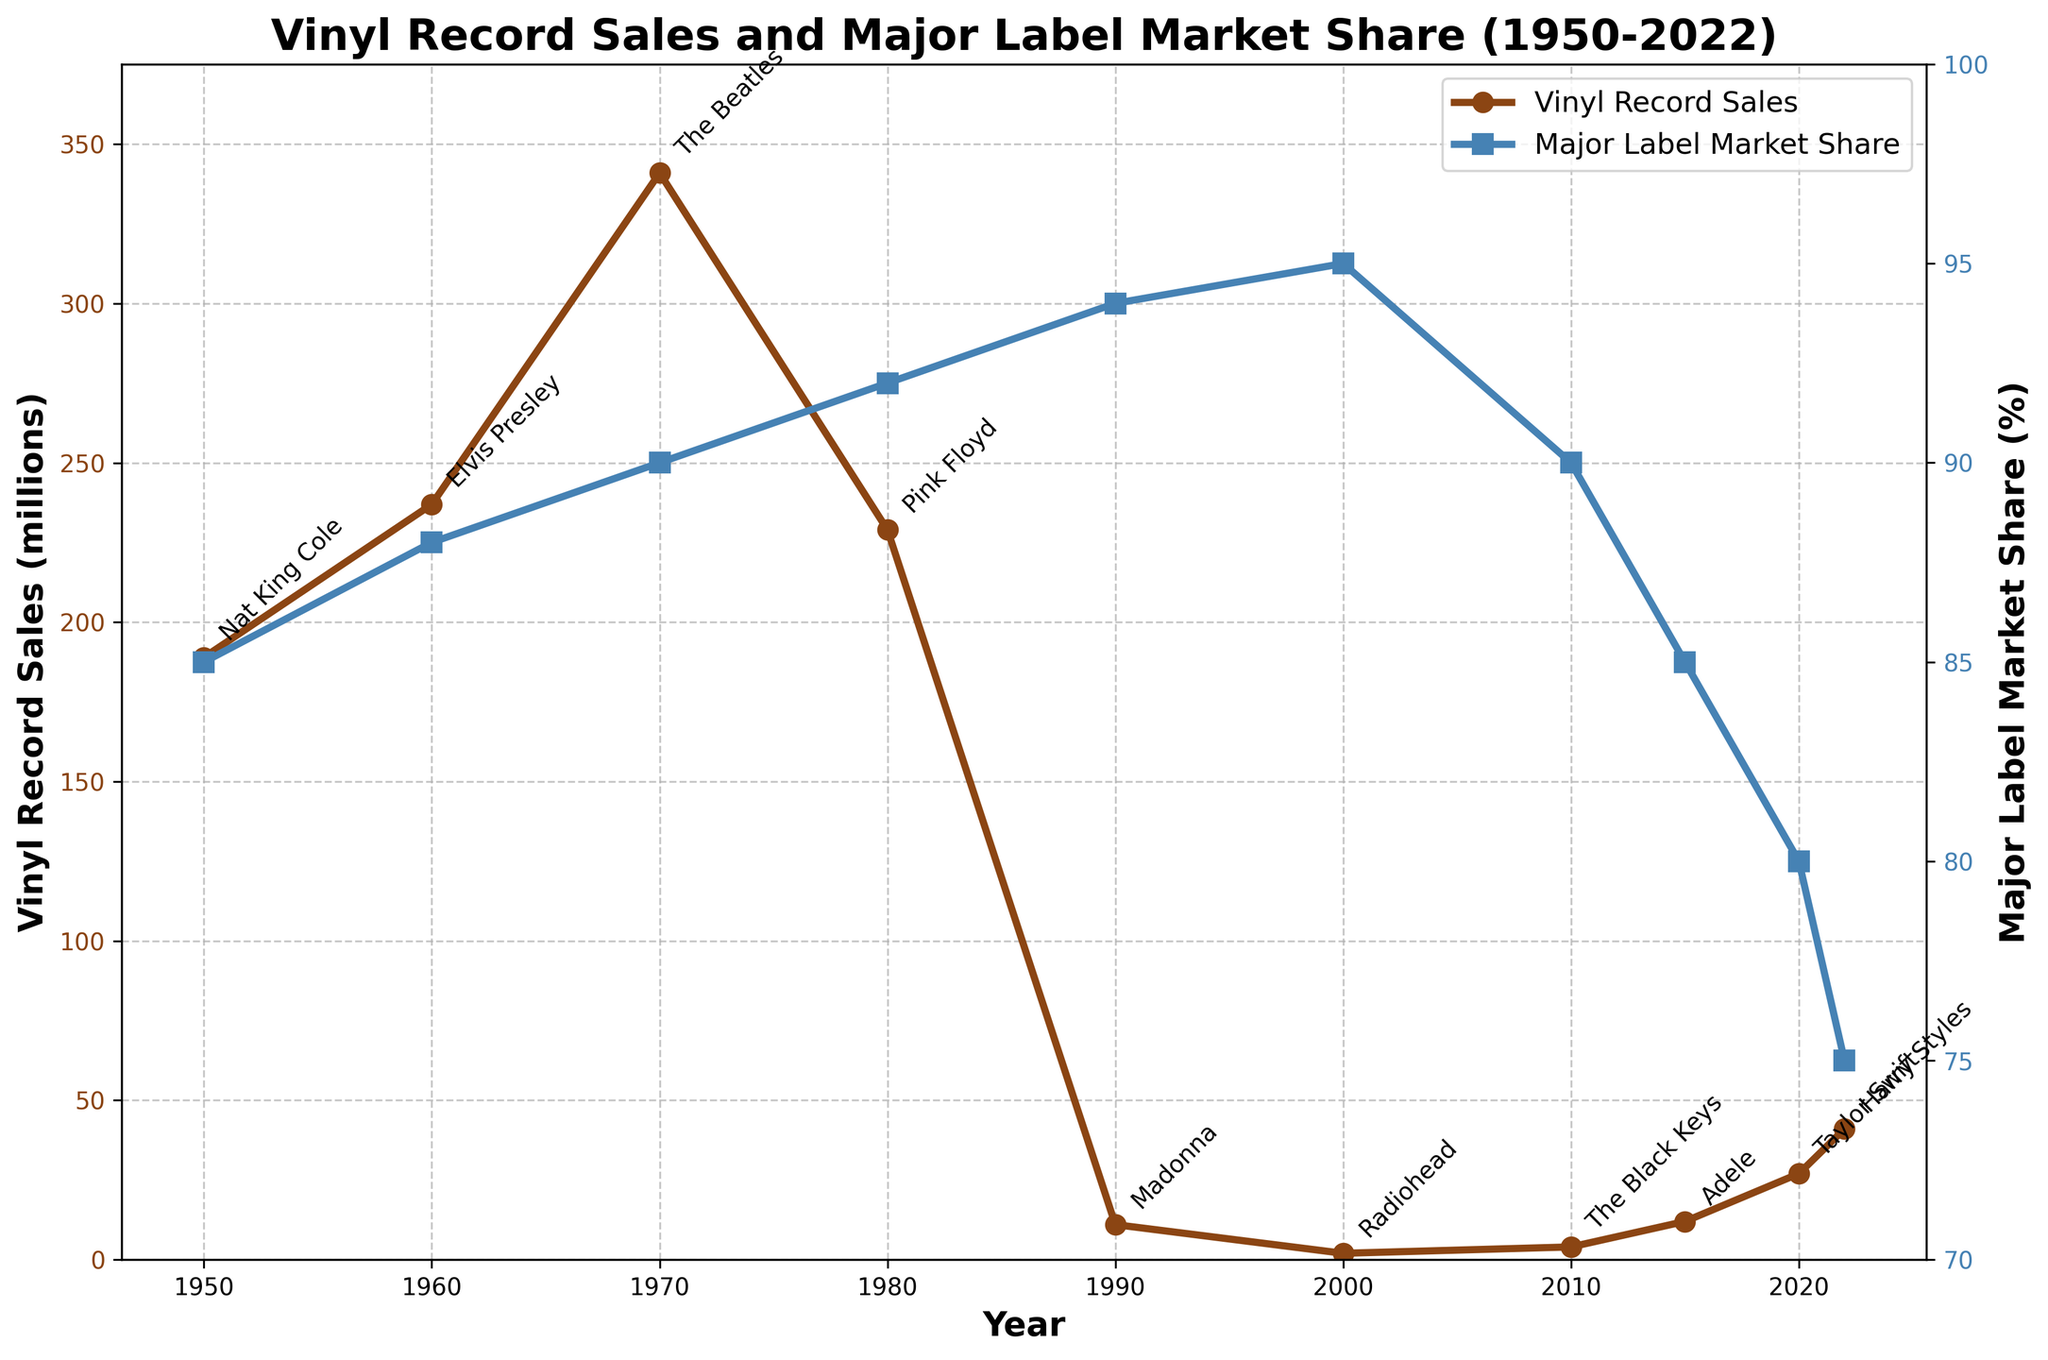What's the lowest point of vinyl record sales in the graph? The lowest point of vinyl record sales is when the data marker is closest to the bottom of the y-axis representing sales. This occurs in the year 2000.
Answer: 2000 What's the increase in vinyl record sales from 2010 to 2020? To find the increase, subtract the sales in 2010 from the sales in 2020. This involves looking at the y-axis values for these years. The sales in 2010 are 4 million, and in 2020, they are 27 million. The increase is 27 - 4 = 23 million.
Answer: 23 million What is the trend of the major label market share from 1950 to 2022? The line representing the major label market share shows a general decline from 1950 to 2022. Initially, it fluctuates around the 90s and then more noticeably drops after 2000.
Answer: Decreasing By how much did the independent label market share increase from 1950 to 2022? First, note the independent label market share in 1950 and 2022, which are 15% and 25% respectively. The increase is 25% - 15% = 10%.
Answer: 10% Which year saw the highest vinyl record sales? Look for the peak point of the line representing vinyl record sales. The highest point is in 1970.
Answer: 1970 Who was the top-selling artist during the year of the lowest vinyl sales? First, identify the year with the lowest vinyl sales, which is 2000. The top-selling artist in that year is Radiohead.
Answer: Radiohead What are the visual differences between the two curves representing vinyl record sales and major label market share? The vinyl record sales line is brown with circles at data points, showing fluctuations and a notable decline in the late 20th century followed by a rise. The major label market share line is blue with square markers and consistently decreases over time.
Answer: Brown line with circles (sales), blue line with squares (market share) How did vinyl record sales and major label market share differ in 2022 compared to 2010? In 2010, sales were 4 million and the major label share was 90%. By 2022, sales increased to 41 million while the major label share dropped to 75%.
Answer: Sales up, market share down 